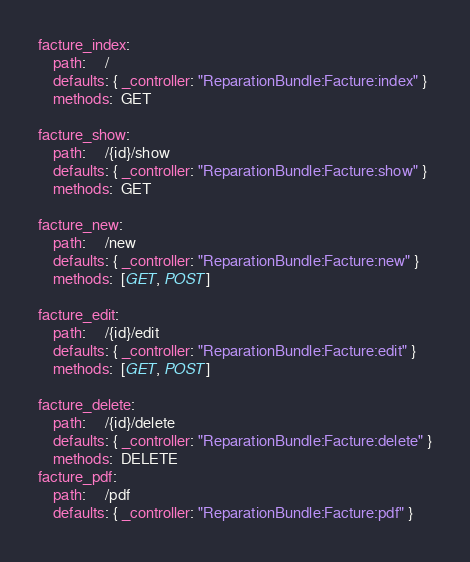<code> <loc_0><loc_0><loc_500><loc_500><_YAML_>facture_index:
    path:     /
    defaults: { _controller: "ReparationBundle:Facture:index" }
    methods:  GET

facture_show:
    path:     /{id}/show
    defaults: { _controller: "ReparationBundle:Facture:show" }
    methods:  GET

facture_new:
    path:     /new
    defaults: { _controller: "ReparationBundle:Facture:new" }
    methods:  [GET, POST]

facture_edit:
    path:     /{id}/edit
    defaults: { _controller: "ReparationBundle:Facture:edit" }
    methods:  [GET, POST]

facture_delete:
    path:     /{id}/delete
    defaults: { _controller: "ReparationBundle:Facture:delete" }
    methods:  DELETE
facture_pdf:
    path:     /pdf
    defaults: { _controller: "ReparationBundle:Facture:pdf" }
</code> 